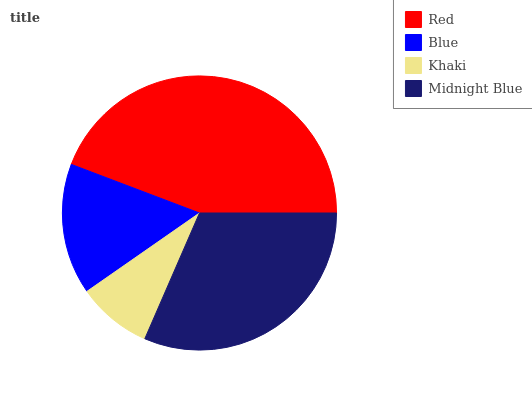Is Khaki the minimum?
Answer yes or no. Yes. Is Red the maximum?
Answer yes or no. Yes. Is Blue the minimum?
Answer yes or no. No. Is Blue the maximum?
Answer yes or no. No. Is Red greater than Blue?
Answer yes or no. Yes. Is Blue less than Red?
Answer yes or no. Yes. Is Blue greater than Red?
Answer yes or no. No. Is Red less than Blue?
Answer yes or no. No. Is Midnight Blue the high median?
Answer yes or no. Yes. Is Blue the low median?
Answer yes or no. Yes. Is Blue the high median?
Answer yes or no. No. Is Khaki the low median?
Answer yes or no. No. 